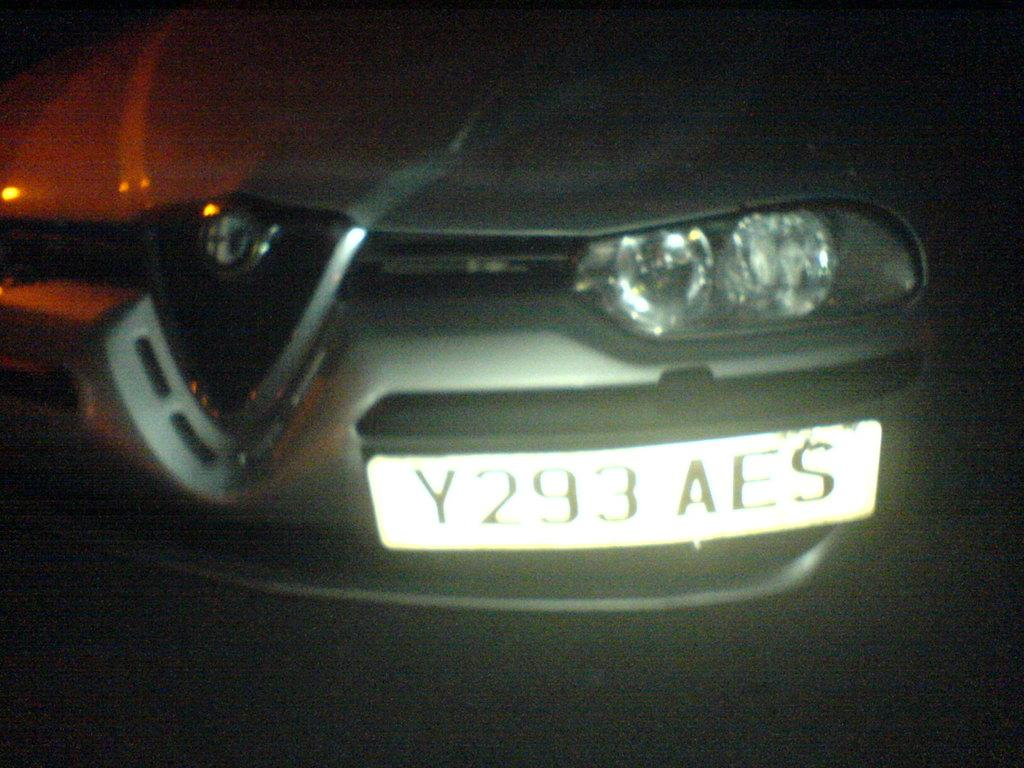What is the main subject of the image? The main subject of the image is a car. Can you describe any specific features of the car? The car has a number plate. Where is the coat hanging in the image? There is no coat present in the image. What type of trouble is the car experiencing in the image? There is no indication of trouble with the car in the image. 